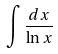<formula> <loc_0><loc_0><loc_500><loc_500>\int \frac { d x } { \ln x }</formula> 